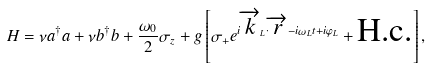<formula> <loc_0><loc_0><loc_500><loc_500>H = \nu a ^ { \dagger } a + \nu b ^ { \dagger } b + \frac { \omega _ { 0 } } { 2 } \sigma _ { z } + g \left [ \sigma _ { + } e ^ { i \overrightarrow { k } _ { L } \cdot \overrightarrow { r } - i \omega _ { L } t + i \varphi _ { L } } + \text {H.c.} \right ] ,</formula> 